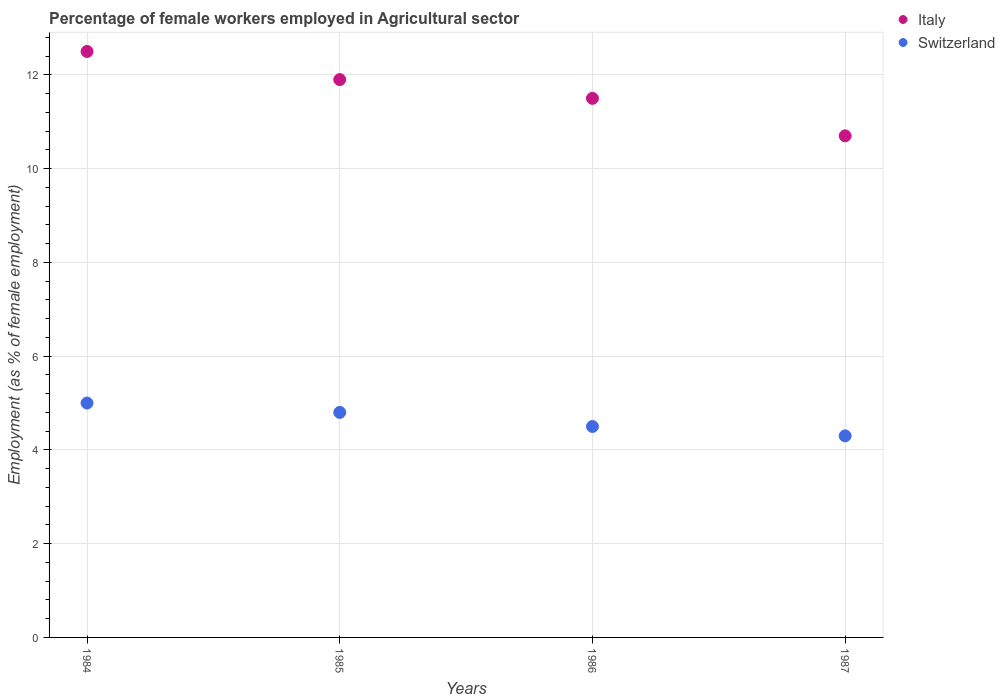What is the percentage of females employed in Agricultural sector in Italy in 1985?
Ensure brevity in your answer.  11.9. Across all years, what is the maximum percentage of females employed in Agricultural sector in Switzerland?
Provide a succinct answer. 5. Across all years, what is the minimum percentage of females employed in Agricultural sector in Switzerland?
Offer a very short reply. 4.3. What is the total percentage of females employed in Agricultural sector in Switzerland in the graph?
Provide a succinct answer. 18.6. What is the difference between the percentage of females employed in Agricultural sector in Switzerland in 1984 and that in 1985?
Ensure brevity in your answer.  0.2. What is the difference between the percentage of females employed in Agricultural sector in Italy in 1985 and the percentage of females employed in Agricultural sector in Switzerland in 1987?
Provide a short and direct response. 7.6. What is the average percentage of females employed in Agricultural sector in Italy per year?
Make the answer very short. 11.65. In the year 1986, what is the difference between the percentage of females employed in Agricultural sector in Switzerland and percentage of females employed in Agricultural sector in Italy?
Ensure brevity in your answer.  -7. What is the ratio of the percentage of females employed in Agricultural sector in Switzerland in 1985 to that in 1987?
Give a very brief answer. 1.12. What is the difference between the highest and the second highest percentage of females employed in Agricultural sector in Italy?
Your answer should be very brief. 0.6. What is the difference between the highest and the lowest percentage of females employed in Agricultural sector in Italy?
Your answer should be very brief. 1.8. In how many years, is the percentage of females employed in Agricultural sector in Switzerland greater than the average percentage of females employed in Agricultural sector in Switzerland taken over all years?
Make the answer very short. 2. Where does the legend appear in the graph?
Make the answer very short. Top right. How many legend labels are there?
Provide a short and direct response. 2. How are the legend labels stacked?
Offer a very short reply. Vertical. What is the title of the graph?
Your answer should be compact. Percentage of female workers employed in Agricultural sector. Does "Zimbabwe" appear as one of the legend labels in the graph?
Provide a succinct answer. No. What is the label or title of the Y-axis?
Keep it short and to the point. Employment (as % of female employment). What is the Employment (as % of female employment) in Italy in 1984?
Ensure brevity in your answer.  12.5. What is the Employment (as % of female employment) of Switzerland in 1984?
Give a very brief answer. 5. What is the Employment (as % of female employment) in Italy in 1985?
Offer a terse response. 11.9. What is the Employment (as % of female employment) in Switzerland in 1985?
Your answer should be compact. 4.8. What is the Employment (as % of female employment) in Italy in 1987?
Offer a terse response. 10.7. What is the Employment (as % of female employment) of Switzerland in 1987?
Ensure brevity in your answer.  4.3. Across all years, what is the minimum Employment (as % of female employment) in Italy?
Your answer should be very brief. 10.7. Across all years, what is the minimum Employment (as % of female employment) in Switzerland?
Ensure brevity in your answer.  4.3. What is the total Employment (as % of female employment) of Italy in the graph?
Offer a terse response. 46.6. What is the total Employment (as % of female employment) of Switzerland in the graph?
Provide a succinct answer. 18.6. What is the difference between the Employment (as % of female employment) in Italy in 1984 and that in 1985?
Offer a terse response. 0.6. What is the difference between the Employment (as % of female employment) in Switzerland in 1984 and that in 1986?
Give a very brief answer. 0.5. What is the difference between the Employment (as % of female employment) in Switzerland in 1984 and that in 1987?
Your answer should be very brief. 0.7. What is the difference between the Employment (as % of female employment) in Italy in 1986 and that in 1987?
Your answer should be compact. 0.8. What is the difference between the Employment (as % of female employment) of Switzerland in 1986 and that in 1987?
Give a very brief answer. 0.2. What is the difference between the Employment (as % of female employment) in Italy in 1984 and the Employment (as % of female employment) in Switzerland in 1985?
Your answer should be compact. 7.7. What is the difference between the Employment (as % of female employment) of Italy in 1984 and the Employment (as % of female employment) of Switzerland in 1986?
Provide a short and direct response. 8. What is the difference between the Employment (as % of female employment) in Italy in 1985 and the Employment (as % of female employment) in Switzerland in 1986?
Your answer should be very brief. 7.4. What is the average Employment (as % of female employment) in Italy per year?
Ensure brevity in your answer.  11.65. What is the average Employment (as % of female employment) in Switzerland per year?
Keep it short and to the point. 4.65. In the year 1984, what is the difference between the Employment (as % of female employment) of Italy and Employment (as % of female employment) of Switzerland?
Make the answer very short. 7.5. In the year 1986, what is the difference between the Employment (as % of female employment) in Italy and Employment (as % of female employment) in Switzerland?
Offer a very short reply. 7. What is the ratio of the Employment (as % of female employment) in Italy in 1984 to that in 1985?
Provide a succinct answer. 1.05. What is the ratio of the Employment (as % of female employment) in Switzerland in 1984 to that in 1985?
Keep it short and to the point. 1.04. What is the ratio of the Employment (as % of female employment) in Italy in 1984 to that in 1986?
Give a very brief answer. 1.09. What is the ratio of the Employment (as % of female employment) in Italy in 1984 to that in 1987?
Ensure brevity in your answer.  1.17. What is the ratio of the Employment (as % of female employment) in Switzerland in 1984 to that in 1987?
Your response must be concise. 1.16. What is the ratio of the Employment (as % of female employment) in Italy in 1985 to that in 1986?
Give a very brief answer. 1.03. What is the ratio of the Employment (as % of female employment) in Switzerland in 1985 to that in 1986?
Make the answer very short. 1.07. What is the ratio of the Employment (as % of female employment) of Italy in 1985 to that in 1987?
Offer a very short reply. 1.11. What is the ratio of the Employment (as % of female employment) in Switzerland in 1985 to that in 1987?
Offer a terse response. 1.12. What is the ratio of the Employment (as % of female employment) in Italy in 1986 to that in 1987?
Provide a succinct answer. 1.07. What is the ratio of the Employment (as % of female employment) in Switzerland in 1986 to that in 1987?
Provide a succinct answer. 1.05. What is the difference between the highest and the lowest Employment (as % of female employment) in Italy?
Offer a very short reply. 1.8. What is the difference between the highest and the lowest Employment (as % of female employment) of Switzerland?
Offer a terse response. 0.7. 